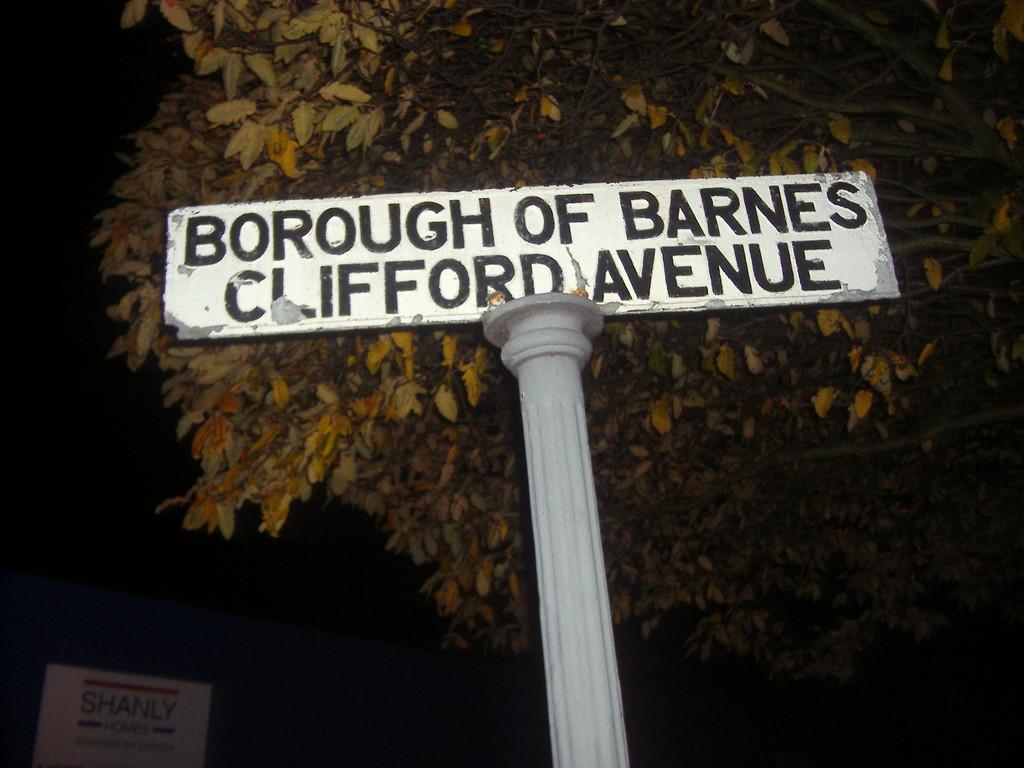Can you describe this image briefly? In this picture, we can see pole with a plate and some text on it, we can see a tree, and we can see an object in the bottom left corner, and the background is dark. 